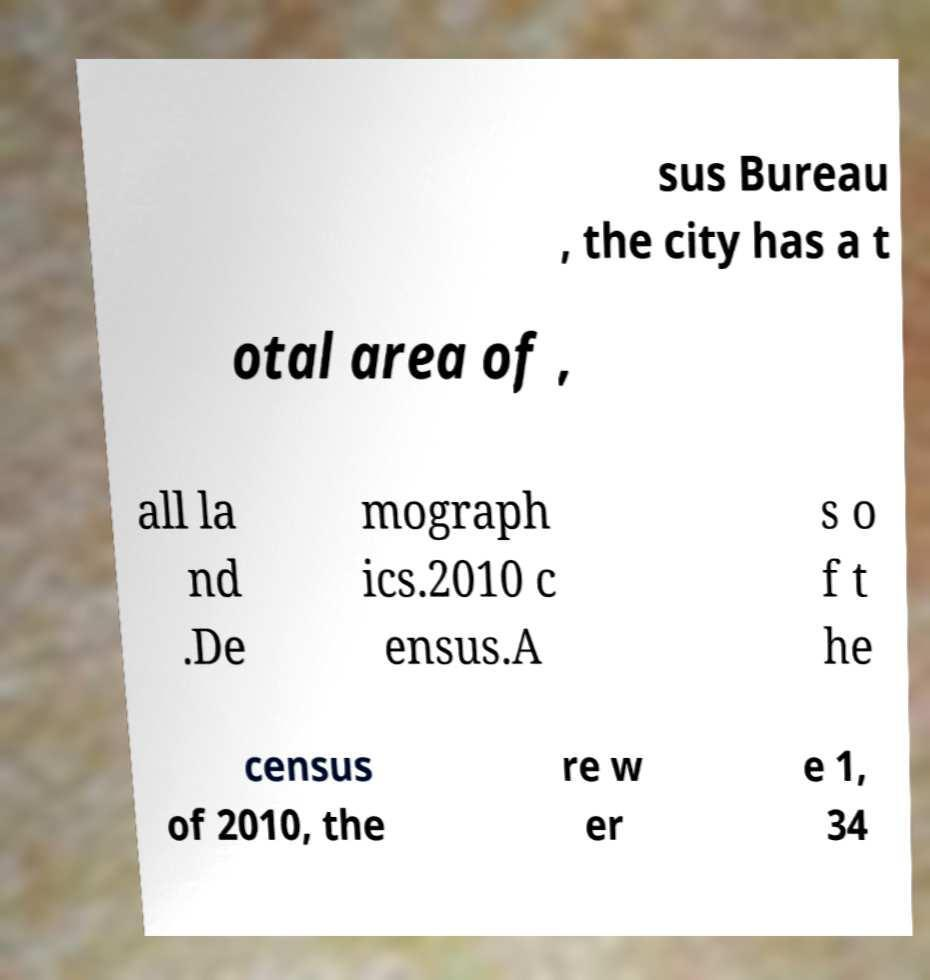Please identify and transcribe the text found in this image. sus Bureau , the city has a t otal area of , all la nd .De mograph ics.2010 c ensus.A s o f t he census of 2010, the re w er e 1, 34 